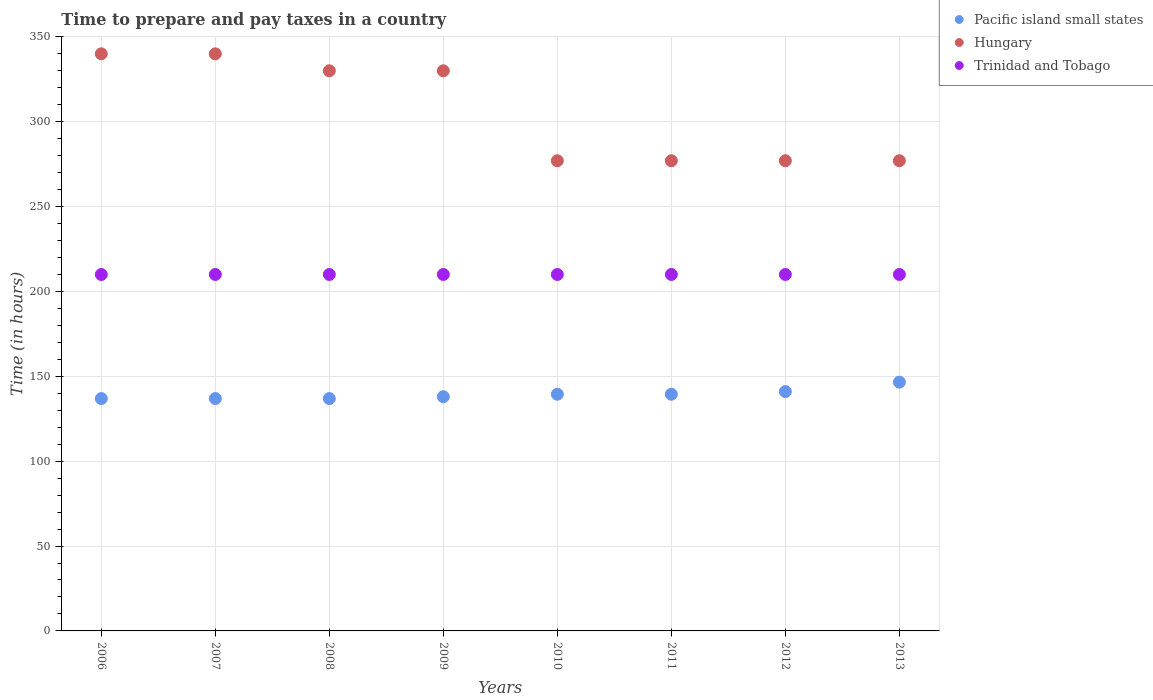Is the number of dotlines equal to the number of legend labels?
Make the answer very short. Yes. What is the number of hours required to prepare and pay taxes in Trinidad and Tobago in 2009?
Your answer should be very brief. 210. Across all years, what is the maximum number of hours required to prepare and pay taxes in Hungary?
Your response must be concise. 340. Across all years, what is the minimum number of hours required to prepare and pay taxes in Pacific island small states?
Keep it short and to the point. 136.89. What is the total number of hours required to prepare and pay taxes in Trinidad and Tobago in the graph?
Your answer should be very brief. 1680. What is the difference between the number of hours required to prepare and pay taxes in Pacific island small states in 2009 and that in 2013?
Your answer should be compact. -8.56. What is the difference between the number of hours required to prepare and pay taxes in Trinidad and Tobago in 2013 and the number of hours required to prepare and pay taxes in Pacific island small states in 2012?
Offer a very short reply. 69. What is the average number of hours required to prepare and pay taxes in Hungary per year?
Offer a very short reply. 306. In the year 2006, what is the difference between the number of hours required to prepare and pay taxes in Hungary and number of hours required to prepare and pay taxes in Trinidad and Tobago?
Ensure brevity in your answer.  130. In how many years, is the number of hours required to prepare and pay taxes in Trinidad and Tobago greater than 220 hours?
Offer a very short reply. 0. What is the ratio of the number of hours required to prepare and pay taxes in Hungary in 2006 to that in 2012?
Offer a terse response. 1.23. Is the number of hours required to prepare and pay taxes in Hungary in 2006 less than that in 2013?
Keep it short and to the point. No. Is the difference between the number of hours required to prepare and pay taxes in Hungary in 2006 and 2009 greater than the difference between the number of hours required to prepare and pay taxes in Trinidad and Tobago in 2006 and 2009?
Your answer should be compact. Yes. What is the difference between the highest and the second highest number of hours required to prepare and pay taxes in Pacific island small states?
Keep it short and to the point. 5.56. What is the difference between the highest and the lowest number of hours required to prepare and pay taxes in Pacific island small states?
Offer a very short reply. 9.67. In how many years, is the number of hours required to prepare and pay taxes in Hungary greater than the average number of hours required to prepare and pay taxes in Hungary taken over all years?
Your answer should be compact. 4. Does the number of hours required to prepare and pay taxes in Hungary monotonically increase over the years?
Keep it short and to the point. No. Is the number of hours required to prepare and pay taxes in Trinidad and Tobago strictly greater than the number of hours required to prepare and pay taxes in Hungary over the years?
Keep it short and to the point. No. How many dotlines are there?
Offer a terse response. 3. How many years are there in the graph?
Give a very brief answer. 8. Are the values on the major ticks of Y-axis written in scientific E-notation?
Your answer should be very brief. No. Where does the legend appear in the graph?
Give a very brief answer. Top right. What is the title of the graph?
Offer a very short reply. Time to prepare and pay taxes in a country. What is the label or title of the Y-axis?
Provide a short and direct response. Time (in hours). What is the Time (in hours) in Pacific island small states in 2006?
Ensure brevity in your answer.  136.89. What is the Time (in hours) in Hungary in 2006?
Give a very brief answer. 340. What is the Time (in hours) of Trinidad and Tobago in 2006?
Keep it short and to the point. 210. What is the Time (in hours) in Pacific island small states in 2007?
Make the answer very short. 136.89. What is the Time (in hours) in Hungary in 2007?
Offer a very short reply. 340. What is the Time (in hours) in Trinidad and Tobago in 2007?
Make the answer very short. 210. What is the Time (in hours) of Pacific island small states in 2008?
Your answer should be very brief. 136.89. What is the Time (in hours) in Hungary in 2008?
Offer a terse response. 330. What is the Time (in hours) in Trinidad and Tobago in 2008?
Ensure brevity in your answer.  210. What is the Time (in hours) of Pacific island small states in 2009?
Offer a very short reply. 138. What is the Time (in hours) in Hungary in 2009?
Offer a terse response. 330. What is the Time (in hours) in Trinidad and Tobago in 2009?
Offer a very short reply. 210. What is the Time (in hours) in Pacific island small states in 2010?
Provide a succinct answer. 139.44. What is the Time (in hours) in Hungary in 2010?
Give a very brief answer. 277. What is the Time (in hours) of Trinidad and Tobago in 2010?
Ensure brevity in your answer.  210. What is the Time (in hours) in Pacific island small states in 2011?
Keep it short and to the point. 139.44. What is the Time (in hours) of Hungary in 2011?
Provide a short and direct response. 277. What is the Time (in hours) of Trinidad and Tobago in 2011?
Offer a terse response. 210. What is the Time (in hours) of Pacific island small states in 2012?
Provide a succinct answer. 141. What is the Time (in hours) of Hungary in 2012?
Offer a very short reply. 277. What is the Time (in hours) of Trinidad and Tobago in 2012?
Provide a succinct answer. 210. What is the Time (in hours) in Pacific island small states in 2013?
Ensure brevity in your answer.  146.56. What is the Time (in hours) in Hungary in 2013?
Keep it short and to the point. 277. What is the Time (in hours) in Trinidad and Tobago in 2013?
Your answer should be compact. 210. Across all years, what is the maximum Time (in hours) in Pacific island small states?
Make the answer very short. 146.56. Across all years, what is the maximum Time (in hours) in Hungary?
Your response must be concise. 340. Across all years, what is the maximum Time (in hours) in Trinidad and Tobago?
Keep it short and to the point. 210. Across all years, what is the minimum Time (in hours) in Pacific island small states?
Keep it short and to the point. 136.89. Across all years, what is the minimum Time (in hours) in Hungary?
Give a very brief answer. 277. Across all years, what is the minimum Time (in hours) in Trinidad and Tobago?
Keep it short and to the point. 210. What is the total Time (in hours) in Pacific island small states in the graph?
Offer a terse response. 1115.11. What is the total Time (in hours) in Hungary in the graph?
Keep it short and to the point. 2448. What is the total Time (in hours) of Trinidad and Tobago in the graph?
Your answer should be very brief. 1680. What is the difference between the Time (in hours) of Pacific island small states in 2006 and that in 2007?
Give a very brief answer. 0. What is the difference between the Time (in hours) in Hungary in 2006 and that in 2007?
Ensure brevity in your answer.  0. What is the difference between the Time (in hours) in Trinidad and Tobago in 2006 and that in 2007?
Give a very brief answer. 0. What is the difference between the Time (in hours) in Pacific island small states in 2006 and that in 2008?
Provide a short and direct response. 0. What is the difference between the Time (in hours) of Hungary in 2006 and that in 2008?
Provide a short and direct response. 10. What is the difference between the Time (in hours) in Pacific island small states in 2006 and that in 2009?
Make the answer very short. -1.11. What is the difference between the Time (in hours) of Pacific island small states in 2006 and that in 2010?
Provide a succinct answer. -2.56. What is the difference between the Time (in hours) of Trinidad and Tobago in 2006 and that in 2010?
Make the answer very short. 0. What is the difference between the Time (in hours) in Pacific island small states in 2006 and that in 2011?
Make the answer very short. -2.56. What is the difference between the Time (in hours) in Hungary in 2006 and that in 2011?
Give a very brief answer. 63. What is the difference between the Time (in hours) in Trinidad and Tobago in 2006 and that in 2011?
Provide a short and direct response. 0. What is the difference between the Time (in hours) of Pacific island small states in 2006 and that in 2012?
Ensure brevity in your answer.  -4.11. What is the difference between the Time (in hours) of Trinidad and Tobago in 2006 and that in 2012?
Ensure brevity in your answer.  0. What is the difference between the Time (in hours) of Pacific island small states in 2006 and that in 2013?
Make the answer very short. -9.67. What is the difference between the Time (in hours) of Hungary in 2006 and that in 2013?
Offer a terse response. 63. What is the difference between the Time (in hours) of Pacific island small states in 2007 and that in 2008?
Ensure brevity in your answer.  0. What is the difference between the Time (in hours) in Hungary in 2007 and that in 2008?
Offer a very short reply. 10. What is the difference between the Time (in hours) in Pacific island small states in 2007 and that in 2009?
Offer a terse response. -1.11. What is the difference between the Time (in hours) in Trinidad and Tobago in 2007 and that in 2009?
Offer a very short reply. 0. What is the difference between the Time (in hours) of Pacific island small states in 2007 and that in 2010?
Offer a terse response. -2.56. What is the difference between the Time (in hours) of Trinidad and Tobago in 2007 and that in 2010?
Ensure brevity in your answer.  0. What is the difference between the Time (in hours) in Pacific island small states in 2007 and that in 2011?
Provide a short and direct response. -2.56. What is the difference between the Time (in hours) of Hungary in 2007 and that in 2011?
Provide a short and direct response. 63. What is the difference between the Time (in hours) of Pacific island small states in 2007 and that in 2012?
Your answer should be compact. -4.11. What is the difference between the Time (in hours) in Pacific island small states in 2007 and that in 2013?
Keep it short and to the point. -9.67. What is the difference between the Time (in hours) in Pacific island small states in 2008 and that in 2009?
Offer a very short reply. -1.11. What is the difference between the Time (in hours) of Trinidad and Tobago in 2008 and that in 2009?
Your response must be concise. 0. What is the difference between the Time (in hours) of Pacific island small states in 2008 and that in 2010?
Provide a short and direct response. -2.56. What is the difference between the Time (in hours) in Hungary in 2008 and that in 2010?
Offer a very short reply. 53. What is the difference between the Time (in hours) in Pacific island small states in 2008 and that in 2011?
Provide a short and direct response. -2.56. What is the difference between the Time (in hours) of Trinidad and Tobago in 2008 and that in 2011?
Your answer should be very brief. 0. What is the difference between the Time (in hours) in Pacific island small states in 2008 and that in 2012?
Keep it short and to the point. -4.11. What is the difference between the Time (in hours) in Pacific island small states in 2008 and that in 2013?
Your answer should be compact. -9.67. What is the difference between the Time (in hours) of Hungary in 2008 and that in 2013?
Offer a terse response. 53. What is the difference between the Time (in hours) of Trinidad and Tobago in 2008 and that in 2013?
Make the answer very short. 0. What is the difference between the Time (in hours) of Pacific island small states in 2009 and that in 2010?
Ensure brevity in your answer.  -1.44. What is the difference between the Time (in hours) in Hungary in 2009 and that in 2010?
Offer a terse response. 53. What is the difference between the Time (in hours) in Pacific island small states in 2009 and that in 2011?
Give a very brief answer. -1.44. What is the difference between the Time (in hours) in Hungary in 2009 and that in 2011?
Keep it short and to the point. 53. What is the difference between the Time (in hours) of Trinidad and Tobago in 2009 and that in 2011?
Make the answer very short. 0. What is the difference between the Time (in hours) of Pacific island small states in 2009 and that in 2012?
Provide a short and direct response. -3. What is the difference between the Time (in hours) in Pacific island small states in 2009 and that in 2013?
Your answer should be very brief. -8.56. What is the difference between the Time (in hours) in Hungary in 2009 and that in 2013?
Give a very brief answer. 53. What is the difference between the Time (in hours) in Pacific island small states in 2010 and that in 2011?
Provide a succinct answer. 0. What is the difference between the Time (in hours) of Hungary in 2010 and that in 2011?
Your response must be concise. 0. What is the difference between the Time (in hours) in Trinidad and Tobago in 2010 and that in 2011?
Your response must be concise. 0. What is the difference between the Time (in hours) in Pacific island small states in 2010 and that in 2012?
Offer a very short reply. -1.56. What is the difference between the Time (in hours) of Trinidad and Tobago in 2010 and that in 2012?
Offer a very short reply. 0. What is the difference between the Time (in hours) of Pacific island small states in 2010 and that in 2013?
Offer a very short reply. -7.11. What is the difference between the Time (in hours) of Hungary in 2010 and that in 2013?
Your answer should be compact. 0. What is the difference between the Time (in hours) of Pacific island small states in 2011 and that in 2012?
Give a very brief answer. -1.56. What is the difference between the Time (in hours) in Hungary in 2011 and that in 2012?
Offer a terse response. 0. What is the difference between the Time (in hours) of Pacific island small states in 2011 and that in 2013?
Provide a succinct answer. -7.11. What is the difference between the Time (in hours) in Hungary in 2011 and that in 2013?
Make the answer very short. 0. What is the difference between the Time (in hours) of Pacific island small states in 2012 and that in 2013?
Offer a very short reply. -5.56. What is the difference between the Time (in hours) in Pacific island small states in 2006 and the Time (in hours) in Hungary in 2007?
Keep it short and to the point. -203.11. What is the difference between the Time (in hours) in Pacific island small states in 2006 and the Time (in hours) in Trinidad and Tobago in 2007?
Give a very brief answer. -73.11. What is the difference between the Time (in hours) of Hungary in 2006 and the Time (in hours) of Trinidad and Tobago in 2007?
Ensure brevity in your answer.  130. What is the difference between the Time (in hours) in Pacific island small states in 2006 and the Time (in hours) in Hungary in 2008?
Provide a succinct answer. -193.11. What is the difference between the Time (in hours) in Pacific island small states in 2006 and the Time (in hours) in Trinidad and Tobago in 2008?
Give a very brief answer. -73.11. What is the difference between the Time (in hours) in Hungary in 2006 and the Time (in hours) in Trinidad and Tobago in 2008?
Make the answer very short. 130. What is the difference between the Time (in hours) of Pacific island small states in 2006 and the Time (in hours) of Hungary in 2009?
Provide a succinct answer. -193.11. What is the difference between the Time (in hours) in Pacific island small states in 2006 and the Time (in hours) in Trinidad and Tobago in 2009?
Provide a succinct answer. -73.11. What is the difference between the Time (in hours) in Hungary in 2006 and the Time (in hours) in Trinidad and Tobago in 2009?
Your answer should be very brief. 130. What is the difference between the Time (in hours) in Pacific island small states in 2006 and the Time (in hours) in Hungary in 2010?
Offer a very short reply. -140.11. What is the difference between the Time (in hours) of Pacific island small states in 2006 and the Time (in hours) of Trinidad and Tobago in 2010?
Give a very brief answer. -73.11. What is the difference between the Time (in hours) of Hungary in 2006 and the Time (in hours) of Trinidad and Tobago in 2010?
Ensure brevity in your answer.  130. What is the difference between the Time (in hours) in Pacific island small states in 2006 and the Time (in hours) in Hungary in 2011?
Make the answer very short. -140.11. What is the difference between the Time (in hours) in Pacific island small states in 2006 and the Time (in hours) in Trinidad and Tobago in 2011?
Offer a very short reply. -73.11. What is the difference between the Time (in hours) of Hungary in 2006 and the Time (in hours) of Trinidad and Tobago in 2011?
Provide a short and direct response. 130. What is the difference between the Time (in hours) of Pacific island small states in 2006 and the Time (in hours) of Hungary in 2012?
Offer a terse response. -140.11. What is the difference between the Time (in hours) in Pacific island small states in 2006 and the Time (in hours) in Trinidad and Tobago in 2012?
Give a very brief answer. -73.11. What is the difference between the Time (in hours) of Hungary in 2006 and the Time (in hours) of Trinidad and Tobago in 2012?
Make the answer very short. 130. What is the difference between the Time (in hours) of Pacific island small states in 2006 and the Time (in hours) of Hungary in 2013?
Offer a very short reply. -140.11. What is the difference between the Time (in hours) in Pacific island small states in 2006 and the Time (in hours) in Trinidad and Tobago in 2013?
Your answer should be compact. -73.11. What is the difference between the Time (in hours) of Hungary in 2006 and the Time (in hours) of Trinidad and Tobago in 2013?
Your answer should be very brief. 130. What is the difference between the Time (in hours) in Pacific island small states in 2007 and the Time (in hours) in Hungary in 2008?
Make the answer very short. -193.11. What is the difference between the Time (in hours) in Pacific island small states in 2007 and the Time (in hours) in Trinidad and Tobago in 2008?
Offer a very short reply. -73.11. What is the difference between the Time (in hours) of Hungary in 2007 and the Time (in hours) of Trinidad and Tobago in 2008?
Give a very brief answer. 130. What is the difference between the Time (in hours) of Pacific island small states in 2007 and the Time (in hours) of Hungary in 2009?
Provide a short and direct response. -193.11. What is the difference between the Time (in hours) of Pacific island small states in 2007 and the Time (in hours) of Trinidad and Tobago in 2009?
Offer a terse response. -73.11. What is the difference between the Time (in hours) in Hungary in 2007 and the Time (in hours) in Trinidad and Tobago in 2009?
Ensure brevity in your answer.  130. What is the difference between the Time (in hours) of Pacific island small states in 2007 and the Time (in hours) of Hungary in 2010?
Offer a terse response. -140.11. What is the difference between the Time (in hours) of Pacific island small states in 2007 and the Time (in hours) of Trinidad and Tobago in 2010?
Provide a short and direct response. -73.11. What is the difference between the Time (in hours) of Hungary in 2007 and the Time (in hours) of Trinidad and Tobago in 2010?
Keep it short and to the point. 130. What is the difference between the Time (in hours) in Pacific island small states in 2007 and the Time (in hours) in Hungary in 2011?
Keep it short and to the point. -140.11. What is the difference between the Time (in hours) of Pacific island small states in 2007 and the Time (in hours) of Trinidad and Tobago in 2011?
Make the answer very short. -73.11. What is the difference between the Time (in hours) in Hungary in 2007 and the Time (in hours) in Trinidad and Tobago in 2011?
Give a very brief answer. 130. What is the difference between the Time (in hours) of Pacific island small states in 2007 and the Time (in hours) of Hungary in 2012?
Your answer should be compact. -140.11. What is the difference between the Time (in hours) of Pacific island small states in 2007 and the Time (in hours) of Trinidad and Tobago in 2012?
Give a very brief answer. -73.11. What is the difference between the Time (in hours) of Hungary in 2007 and the Time (in hours) of Trinidad and Tobago in 2012?
Your answer should be compact. 130. What is the difference between the Time (in hours) of Pacific island small states in 2007 and the Time (in hours) of Hungary in 2013?
Make the answer very short. -140.11. What is the difference between the Time (in hours) of Pacific island small states in 2007 and the Time (in hours) of Trinidad and Tobago in 2013?
Your answer should be very brief. -73.11. What is the difference between the Time (in hours) in Hungary in 2007 and the Time (in hours) in Trinidad and Tobago in 2013?
Your response must be concise. 130. What is the difference between the Time (in hours) of Pacific island small states in 2008 and the Time (in hours) of Hungary in 2009?
Keep it short and to the point. -193.11. What is the difference between the Time (in hours) of Pacific island small states in 2008 and the Time (in hours) of Trinidad and Tobago in 2009?
Offer a very short reply. -73.11. What is the difference between the Time (in hours) of Hungary in 2008 and the Time (in hours) of Trinidad and Tobago in 2009?
Give a very brief answer. 120. What is the difference between the Time (in hours) of Pacific island small states in 2008 and the Time (in hours) of Hungary in 2010?
Ensure brevity in your answer.  -140.11. What is the difference between the Time (in hours) of Pacific island small states in 2008 and the Time (in hours) of Trinidad and Tobago in 2010?
Offer a very short reply. -73.11. What is the difference between the Time (in hours) in Hungary in 2008 and the Time (in hours) in Trinidad and Tobago in 2010?
Make the answer very short. 120. What is the difference between the Time (in hours) of Pacific island small states in 2008 and the Time (in hours) of Hungary in 2011?
Make the answer very short. -140.11. What is the difference between the Time (in hours) in Pacific island small states in 2008 and the Time (in hours) in Trinidad and Tobago in 2011?
Your answer should be compact. -73.11. What is the difference between the Time (in hours) of Hungary in 2008 and the Time (in hours) of Trinidad and Tobago in 2011?
Your answer should be compact. 120. What is the difference between the Time (in hours) in Pacific island small states in 2008 and the Time (in hours) in Hungary in 2012?
Provide a succinct answer. -140.11. What is the difference between the Time (in hours) in Pacific island small states in 2008 and the Time (in hours) in Trinidad and Tobago in 2012?
Keep it short and to the point. -73.11. What is the difference between the Time (in hours) of Hungary in 2008 and the Time (in hours) of Trinidad and Tobago in 2012?
Give a very brief answer. 120. What is the difference between the Time (in hours) of Pacific island small states in 2008 and the Time (in hours) of Hungary in 2013?
Ensure brevity in your answer.  -140.11. What is the difference between the Time (in hours) in Pacific island small states in 2008 and the Time (in hours) in Trinidad and Tobago in 2013?
Ensure brevity in your answer.  -73.11. What is the difference between the Time (in hours) in Hungary in 2008 and the Time (in hours) in Trinidad and Tobago in 2013?
Your response must be concise. 120. What is the difference between the Time (in hours) of Pacific island small states in 2009 and the Time (in hours) of Hungary in 2010?
Ensure brevity in your answer.  -139. What is the difference between the Time (in hours) in Pacific island small states in 2009 and the Time (in hours) in Trinidad and Tobago in 2010?
Keep it short and to the point. -72. What is the difference between the Time (in hours) in Hungary in 2009 and the Time (in hours) in Trinidad and Tobago in 2010?
Offer a terse response. 120. What is the difference between the Time (in hours) of Pacific island small states in 2009 and the Time (in hours) of Hungary in 2011?
Provide a succinct answer. -139. What is the difference between the Time (in hours) in Pacific island small states in 2009 and the Time (in hours) in Trinidad and Tobago in 2011?
Make the answer very short. -72. What is the difference between the Time (in hours) in Hungary in 2009 and the Time (in hours) in Trinidad and Tobago in 2011?
Your response must be concise. 120. What is the difference between the Time (in hours) of Pacific island small states in 2009 and the Time (in hours) of Hungary in 2012?
Keep it short and to the point. -139. What is the difference between the Time (in hours) of Pacific island small states in 2009 and the Time (in hours) of Trinidad and Tobago in 2012?
Provide a short and direct response. -72. What is the difference between the Time (in hours) in Hungary in 2009 and the Time (in hours) in Trinidad and Tobago in 2012?
Offer a very short reply. 120. What is the difference between the Time (in hours) of Pacific island small states in 2009 and the Time (in hours) of Hungary in 2013?
Your answer should be compact. -139. What is the difference between the Time (in hours) of Pacific island small states in 2009 and the Time (in hours) of Trinidad and Tobago in 2013?
Give a very brief answer. -72. What is the difference between the Time (in hours) in Hungary in 2009 and the Time (in hours) in Trinidad and Tobago in 2013?
Your answer should be compact. 120. What is the difference between the Time (in hours) in Pacific island small states in 2010 and the Time (in hours) in Hungary in 2011?
Give a very brief answer. -137.56. What is the difference between the Time (in hours) in Pacific island small states in 2010 and the Time (in hours) in Trinidad and Tobago in 2011?
Give a very brief answer. -70.56. What is the difference between the Time (in hours) of Hungary in 2010 and the Time (in hours) of Trinidad and Tobago in 2011?
Offer a very short reply. 67. What is the difference between the Time (in hours) of Pacific island small states in 2010 and the Time (in hours) of Hungary in 2012?
Your answer should be very brief. -137.56. What is the difference between the Time (in hours) in Pacific island small states in 2010 and the Time (in hours) in Trinidad and Tobago in 2012?
Give a very brief answer. -70.56. What is the difference between the Time (in hours) of Pacific island small states in 2010 and the Time (in hours) of Hungary in 2013?
Ensure brevity in your answer.  -137.56. What is the difference between the Time (in hours) of Pacific island small states in 2010 and the Time (in hours) of Trinidad and Tobago in 2013?
Keep it short and to the point. -70.56. What is the difference between the Time (in hours) in Pacific island small states in 2011 and the Time (in hours) in Hungary in 2012?
Keep it short and to the point. -137.56. What is the difference between the Time (in hours) of Pacific island small states in 2011 and the Time (in hours) of Trinidad and Tobago in 2012?
Keep it short and to the point. -70.56. What is the difference between the Time (in hours) of Hungary in 2011 and the Time (in hours) of Trinidad and Tobago in 2012?
Give a very brief answer. 67. What is the difference between the Time (in hours) in Pacific island small states in 2011 and the Time (in hours) in Hungary in 2013?
Make the answer very short. -137.56. What is the difference between the Time (in hours) of Pacific island small states in 2011 and the Time (in hours) of Trinidad and Tobago in 2013?
Your response must be concise. -70.56. What is the difference between the Time (in hours) in Hungary in 2011 and the Time (in hours) in Trinidad and Tobago in 2013?
Provide a succinct answer. 67. What is the difference between the Time (in hours) of Pacific island small states in 2012 and the Time (in hours) of Hungary in 2013?
Provide a succinct answer. -136. What is the difference between the Time (in hours) of Pacific island small states in 2012 and the Time (in hours) of Trinidad and Tobago in 2013?
Provide a short and direct response. -69. What is the difference between the Time (in hours) in Hungary in 2012 and the Time (in hours) in Trinidad and Tobago in 2013?
Your response must be concise. 67. What is the average Time (in hours) of Pacific island small states per year?
Ensure brevity in your answer.  139.39. What is the average Time (in hours) of Hungary per year?
Keep it short and to the point. 306. What is the average Time (in hours) of Trinidad and Tobago per year?
Give a very brief answer. 210. In the year 2006, what is the difference between the Time (in hours) of Pacific island small states and Time (in hours) of Hungary?
Your answer should be very brief. -203.11. In the year 2006, what is the difference between the Time (in hours) of Pacific island small states and Time (in hours) of Trinidad and Tobago?
Ensure brevity in your answer.  -73.11. In the year 2006, what is the difference between the Time (in hours) in Hungary and Time (in hours) in Trinidad and Tobago?
Offer a terse response. 130. In the year 2007, what is the difference between the Time (in hours) of Pacific island small states and Time (in hours) of Hungary?
Ensure brevity in your answer.  -203.11. In the year 2007, what is the difference between the Time (in hours) of Pacific island small states and Time (in hours) of Trinidad and Tobago?
Ensure brevity in your answer.  -73.11. In the year 2007, what is the difference between the Time (in hours) of Hungary and Time (in hours) of Trinidad and Tobago?
Your answer should be very brief. 130. In the year 2008, what is the difference between the Time (in hours) of Pacific island small states and Time (in hours) of Hungary?
Keep it short and to the point. -193.11. In the year 2008, what is the difference between the Time (in hours) of Pacific island small states and Time (in hours) of Trinidad and Tobago?
Offer a terse response. -73.11. In the year 2008, what is the difference between the Time (in hours) in Hungary and Time (in hours) in Trinidad and Tobago?
Provide a short and direct response. 120. In the year 2009, what is the difference between the Time (in hours) in Pacific island small states and Time (in hours) in Hungary?
Make the answer very short. -192. In the year 2009, what is the difference between the Time (in hours) in Pacific island small states and Time (in hours) in Trinidad and Tobago?
Provide a succinct answer. -72. In the year 2009, what is the difference between the Time (in hours) in Hungary and Time (in hours) in Trinidad and Tobago?
Give a very brief answer. 120. In the year 2010, what is the difference between the Time (in hours) in Pacific island small states and Time (in hours) in Hungary?
Ensure brevity in your answer.  -137.56. In the year 2010, what is the difference between the Time (in hours) of Pacific island small states and Time (in hours) of Trinidad and Tobago?
Your answer should be compact. -70.56. In the year 2011, what is the difference between the Time (in hours) in Pacific island small states and Time (in hours) in Hungary?
Keep it short and to the point. -137.56. In the year 2011, what is the difference between the Time (in hours) in Pacific island small states and Time (in hours) in Trinidad and Tobago?
Your answer should be very brief. -70.56. In the year 2012, what is the difference between the Time (in hours) of Pacific island small states and Time (in hours) of Hungary?
Keep it short and to the point. -136. In the year 2012, what is the difference between the Time (in hours) of Pacific island small states and Time (in hours) of Trinidad and Tobago?
Make the answer very short. -69. In the year 2013, what is the difference between the Time (in hours) of Pacific island small states and Time (in hours) of Hungary?
Provide a short and direct response. -130.44. In the year 2013, what is the difference between the Time (in hours) in Pacific island small states and Time (in hours) in Trinidad and Tobago?
Make the answer very short. -63.44. In the year 2013, what is the difference between the Time (in hours) of Hungary and Time (in hours) of Trinidad and Tobago?
Your response must be concise. 67. What is the ratio of the Time (in hours) of Hungary in 2006 to that in 2007?
Your response must be concise. 1. What is the ratio of the Time (in hours) of Trinidad and Tobago in 2006 to that in 2007?
Provide a succinct answer. 1. What is the ratio of the Time (in hours) in Pacific island small states in 2006 to that in 2008?
Your answer should be very brief. 1. What is the ratio of the Time (in hours) of Hungary in 2006 to that in 2008?
Offer a very short reply. 1.03. What is the ratio of the Time (in hours) in Hungary in 2006 to that in 2009?
Provide a short and direct response. 1.03. What is the ratio of the Time (in hours) in Trinidad and Tobago in 2006 to that in 2009?
Provide a short and direct response. 1. What is the ratio of the Time (in hours) in Pacific island small states in 2006 to that in 2010?
Ensure brevity in your answer.  0.98. What is the ratio of the Time (in hours) of Hungary in 2006 to that in 2010?
Give a very brief answer. 1.23. What is the ratio of the Time (in hours) in Pacific island small states in 2006 to that in 2011?
Your answer should be very brief. 0.98. What is the ratio of the Time (in hours) of Hungary in 2006 to that in 2011?
Give a very brief answer. 1.23. What is the ratio of the Time (in hours) in Pacific island small states in 2006 to that in 2012?
Provide a succinct answer. 0.97. What is the ratio of the Time (in hours) of Hungary in 2006 to that in 2012?
Offer a very short reply. 1.23. What is the ratio of the Time (in hours) of Trinidad and Tobago in 2006 to that in 2012?
Make the answer very short. 1. What is the ratio of the Time (in hours) in Pacific island small states in 2006 to that in 2013?
Offer a terse response. 0.93. What is the ratio of the Time (in hours) of Hungary in 2006 to that in 2013?
Give a very brief answer. 1.23. What is the ratio of the Time (in hours) in Hungary in 2007 to that in 2008?
Ensure brevity in your answer.  1.03. What is the ratio of the Time (in hours) in Trinidad and Tobago in 2007 to that in 2008?
Provide a short and direct response. 1. What is the ratio of the Time (in hours) in Pacific island small states in 2007 to that in 2009?
Your answer should be compact. 0.99. What is the ratio of the Time (in hours) of Hungary in 2007 to that in 2009?
Offer a terse response. 1.03. What is the ratio of the Time (in hours) in Trinidad and Tobago in 2007 to that in 2009?
Your answer should be very brief. 1. What is the ratio of the Time (in hours) of Pacific island small states in 2007 to that in 2010?
Provide a succinct answer. 0.98. What is the ratio of the Time (in hours) of Hungary in 2007 to that in 2010?
Provide a short and direct response. 1.23. What is the ratio of the Time (in hours) of Trinidad and Tobago in 2007 to that in 2010?
Your response must be concise. 1. What is the ratio of the Time (in hours) in Pacific island small states in 2007 to that in 2011?
Offer a very short reply. 0.98. What is the ratio of the Time (in hours) of Hungary in 2007 to that in 2011?
Provide a succinct answer. 1.23. What is the ratio of the Time (in hours) of Pacific island small states in 2007 to that in 2012?
Offer a terse response. 0.97. What is the ratio of the Time (in hours) in Hungary in 2007 to that in 2012?
Provide a succinct answer. 1.23. What is the ratio of the Time (in hours) in Trinidad and Tobago in 2007 to that in 2012?
Provide a short and direct response. 1. What is the ratio of the Time (in hours) of Pacific island small states in 2007 to that in 2013?
Your answer should be very brief. 0.93. What is the ratio of the Time (in hours) of Hungary in 2007 to that in 2013?
Offer a very short reply. 1.23. What is the ratio of the Time (in hours) in Pacific island small states in 2008 to that in 2009?
Provide a short and direct response. 0.99. What is the ratio of the Time (in hours) in Pacific island small states in 2008 to that in 2010?
Offer a very short reply. 0.98. What is the ratio of the Time (in hours) of Hungary in 2008 to that in 2010?
Keep it short and to the point. 1.19. What is the ratio of the Time (in hours) of Trinidad and Tobago in 2008 to that in 2010?
Your response must be concise. 1. What is the ratio of the Time (in hours) in Pacific island small states in 2008 to that in 2011?
Your response must be concise. 0.98. What is the ratio of the Time (in hours) in Hungary in 2008 to that in 2011?
Your answer should be very brief. 1.19. What is the ratio of the Time (in hours) in Pacific island small states in 2008 to that in 2012?
Your answer should be very brief. 0.97. What is the ratio of the Time (in hours) of Hungary in 2008 to that in 2012?
Offer a terse response. 1.19. What is the ratio of the Time (in hours) in Pacific island small states in 2008 to that in 2013?
Keep it short and to the point. 0.93. What is the ratio of the Time (in hours) of Hungary in 2008 to that in 2013?
Offer a terse response. 1.19. What is the ratio of the Time (in hours) in Hungary in 2009 to that in 2010?
Your answer should be very brief. 1.19. What is the ratio of the Time (in hours) of Hungary in 2009 to that in 2011?
Your answer should be compact. 1.19. What is the ratio of the Time (in hours) in Trinidad and Tobago in 2009 to that in 2011?
Your answer should be compact. 1. What is the ratio of the Time (in hours) of Pacific island small states in 2009 to that in 2012?
Offer a very short reply. 0.98. What is the ratio of the Time (in hours) in Hungary in 2009 to that in 2012?
Offer a terse response. 1.19. What is the ratio of the Time (in hours) of Pacific island small states in 2009 to that in 2013?
Your response must be concise. 0.94. What is the ratio of the Time (in hours) of Hungary in 2009 to that in 2013?
Keep it short and to the point. 1.19. What is the ratio of the Time (in hours) of Trinidad and Tobago in 2009 to that in 2013?
Your answer should be compact. 1. What is the ratio of the Time (in hours) of Pacific island small states in 2010 to that in 2011?
Make the answer very short. 1. What is the ratio of the Time (in hours) of Hungary in 2010 to that in 2012?
Your response must be concise. 1. What is the ratio of the Time (in hours) of Trinidad and Tobago in 2010 to that in 2012?
Your answer should be very brief. 1. What is the ratio of the Time (in hours) in Pacific island small states in 2010 to that in 2013?
Your answer should be compact. 0.95. What is the ratio of the Time (in hours) of Hungary in 2010 to that in 2013?
Offer a terse response. 1. What is the ratio of the Time (in hours) in Trinidad and Tobago in 2010 to that in 2013?
Provide a succinct answer. 1. What is the ratio of the Time (in hours) in Pacific island small states in 2011 to that in 2012?
Your answer should be compact. 0.99. What is the ratio of the Time (in hours) of Hungary in 2011 to that in 2012?
Give a very brief answer. 1. What is the ratio of the Time (in hours) of Pacific island small states in 2011 to that in 2013?
Give a very brief answer. 0.95. What is the ratio of the Time (in hours) of Hungary in 2011 to that in 2013?
Keep it short and to the point. 1. What is the ratio of the Time (in hours) in Trinidad and Tobago in 2011 to that in 2013?
Ensure brevity in your answer.  1. What is the ratio of the Time (in hours) of Pacific island small states in 2012 to that in 2013?
Offer a terse response. 0.96. What is the ratio of the Time (in hours) in Hungary in 2012 to that in 2013?
Provide a succinct answer. 1. What is the difference between the highest and the second highest Time (in hours) in Pacific island small states?
Your answer should be compact. 5.56. What is the difference between the highest and the second highest Time (in hours) in Hungary?
Give a very brief answer. 0. What is the difference between the highest and the lowest Time (in hours) in Pacific island small states?
Make the answer very short. 9.67. What is the difference between the highest and the lowest Time (in hours) of Trinidad and Tobago?
Offer a very short reply. 0. 